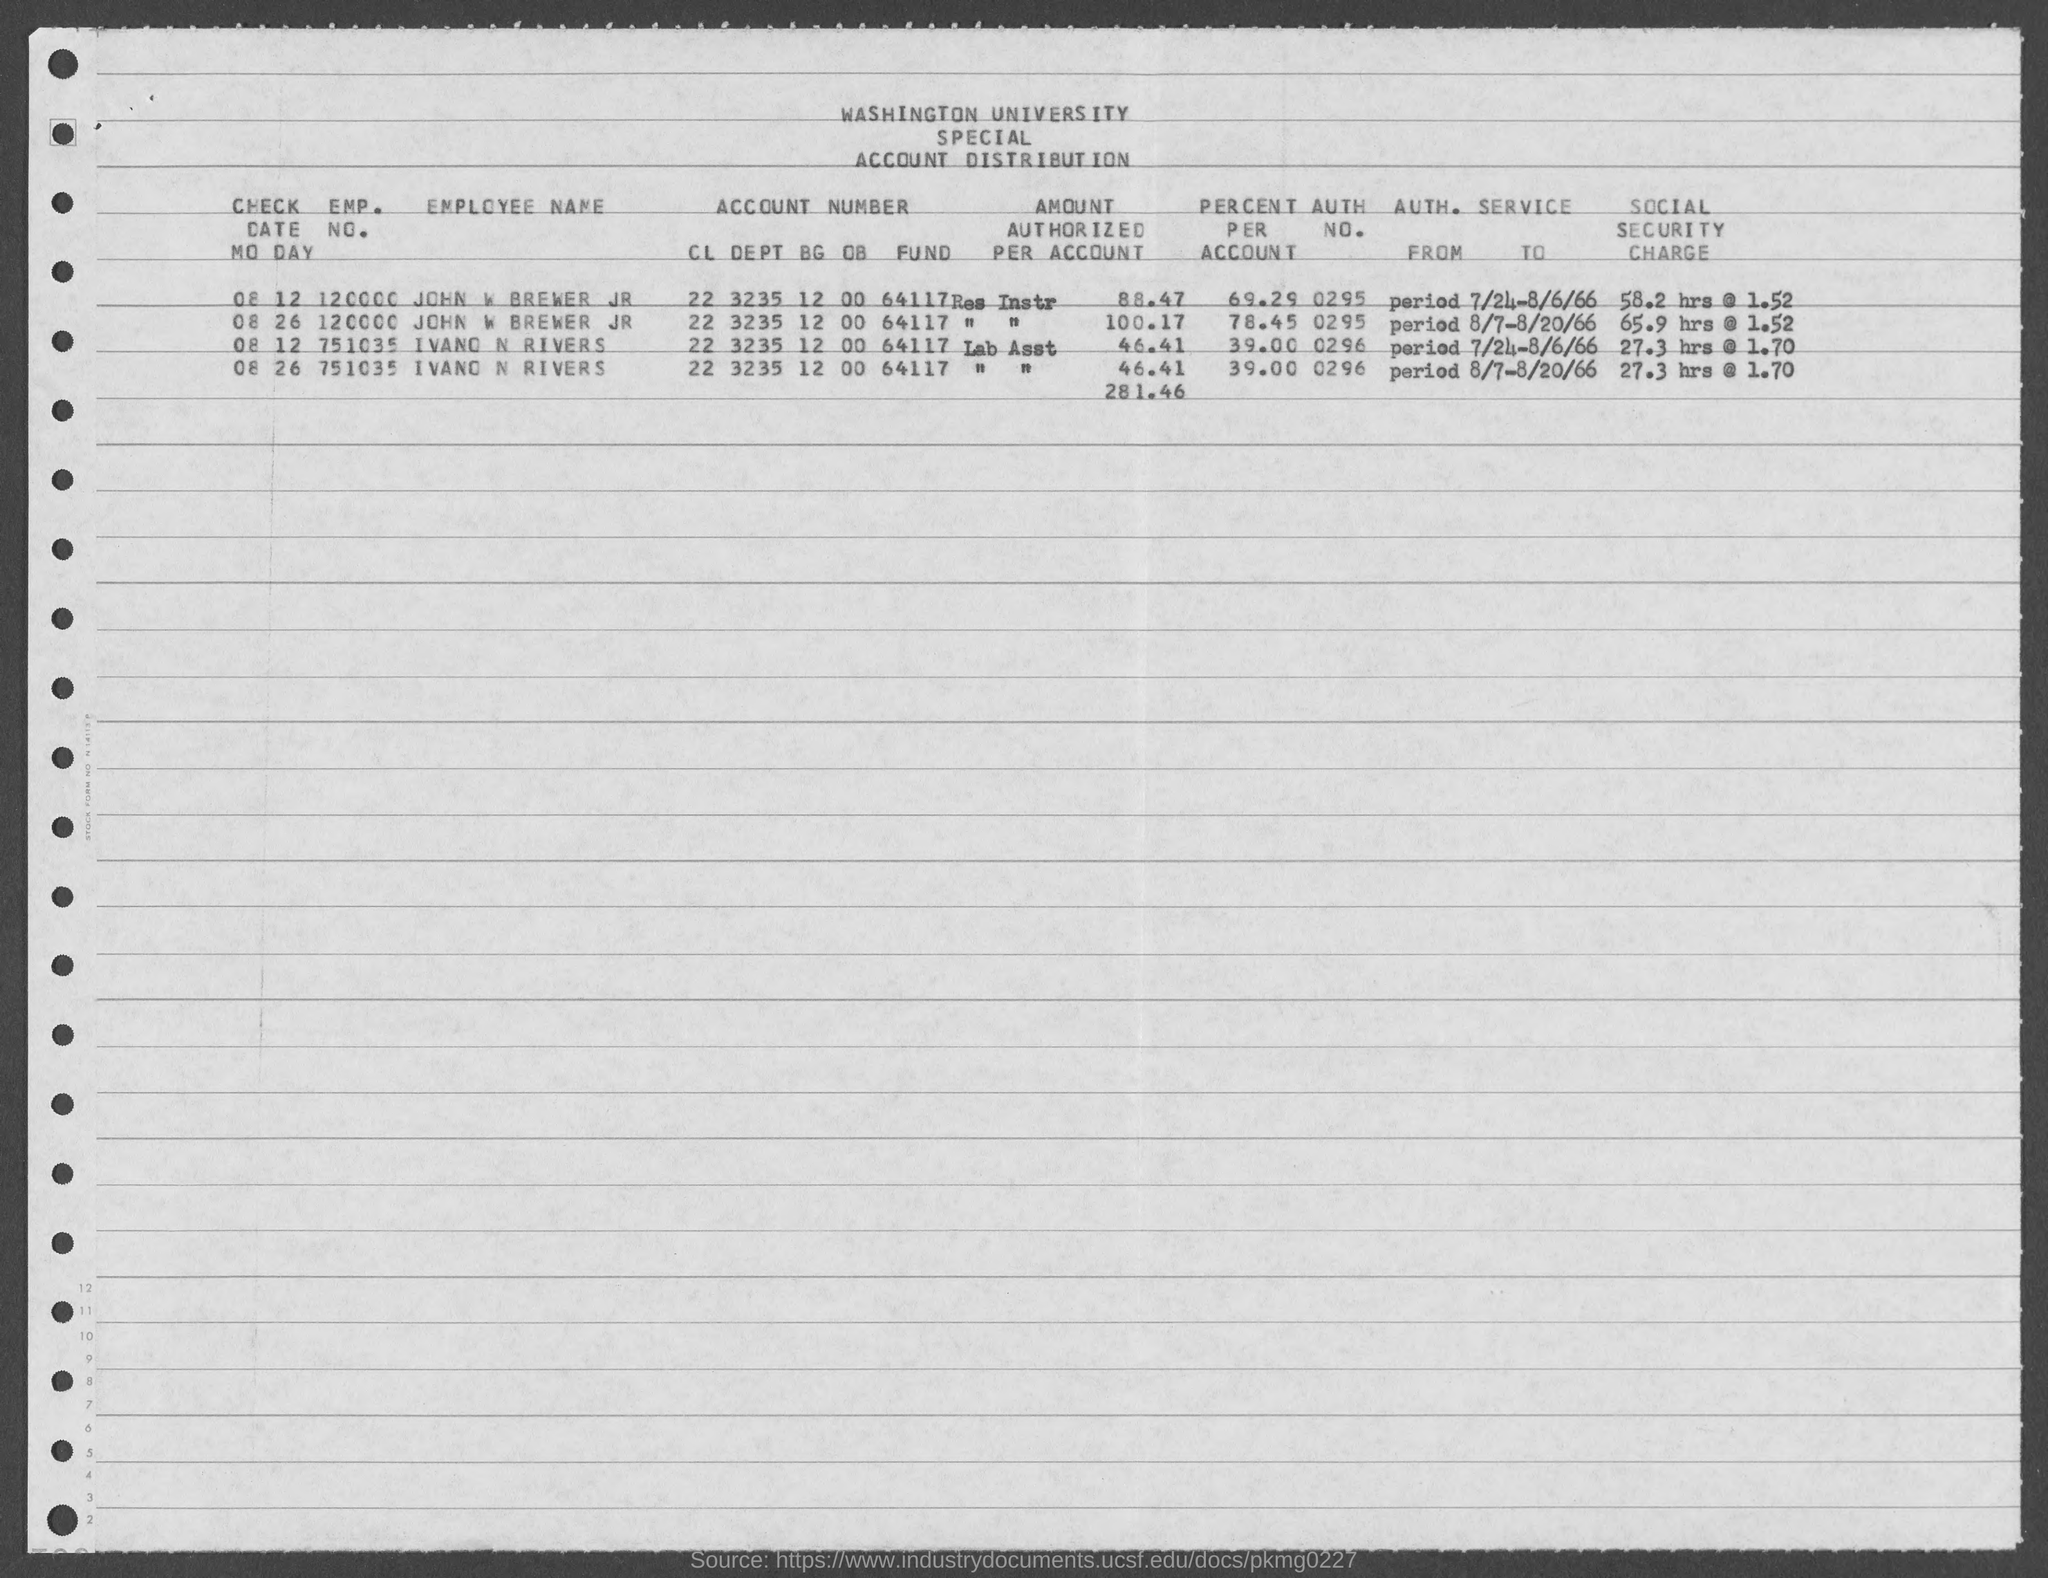What is the name of the university mentioned in the given form ?
Provide a succinct answer. Washington university. What is the auth no. for john w brewer jr ?
Ensure brevity in your answer.  0295. `what is the auth no. for inavo n rivers ?
Give a very brief answer. 0296. What is the emp. no. of john w brewer jr as mentioned in the given page ?
Offer a terse response. 120000. What is the emp. no. of ivano n rivers as mentioned in the given page ?
Your answer should be very brief. 751035. What is the value of percent per account for ivano n rivers as mentioned in the given form ?
Offer a terse response. 39. 